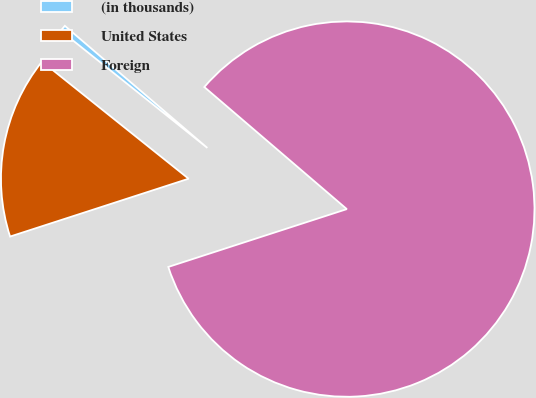<chart> <loc_0><loc_0><loc_500><loc_500><pie_chart><fcel>(in thousands)<fcel>United States<fcel>Foreign<nl><fcel>0.54%<fcel>15.72%<fcel>83.74%<nl></chart> 